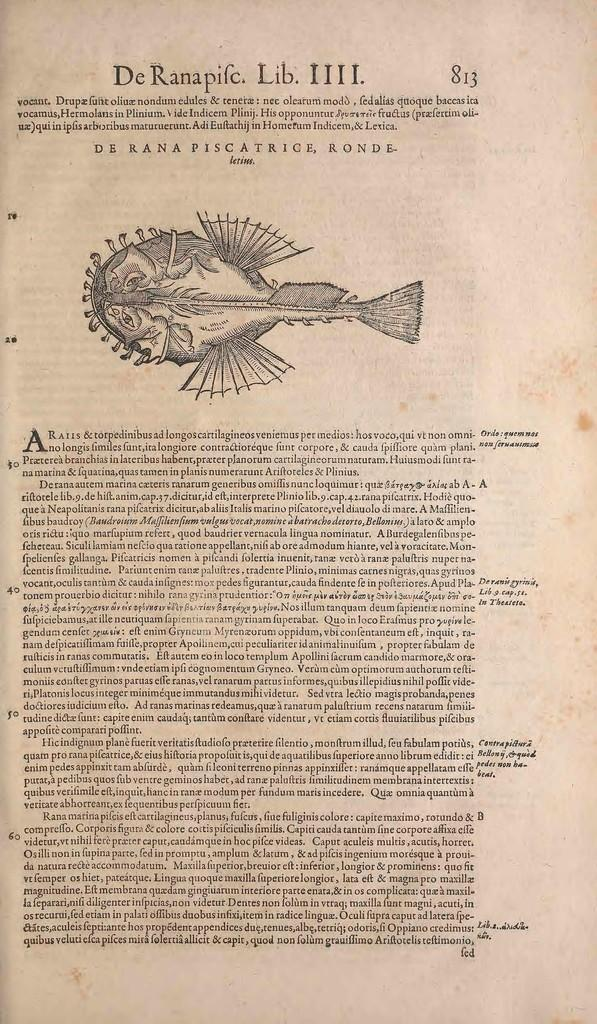What is the main object in the image? The image contains a paper. What can be found on the paper? There are numbers and paragraphs on the paper. How can the paper be identified or referenced? The paper has a page number. What type of content is depicted on the paper? There is an image of an animal on the paper. What color is the curtain hanging behind the animal in the image? There is no curtain present in the image; it only contains a paper with an image of an animal. How much honey is being consumed by the animal in the image? There is no indication of honey or any animal consuming it in the image. 